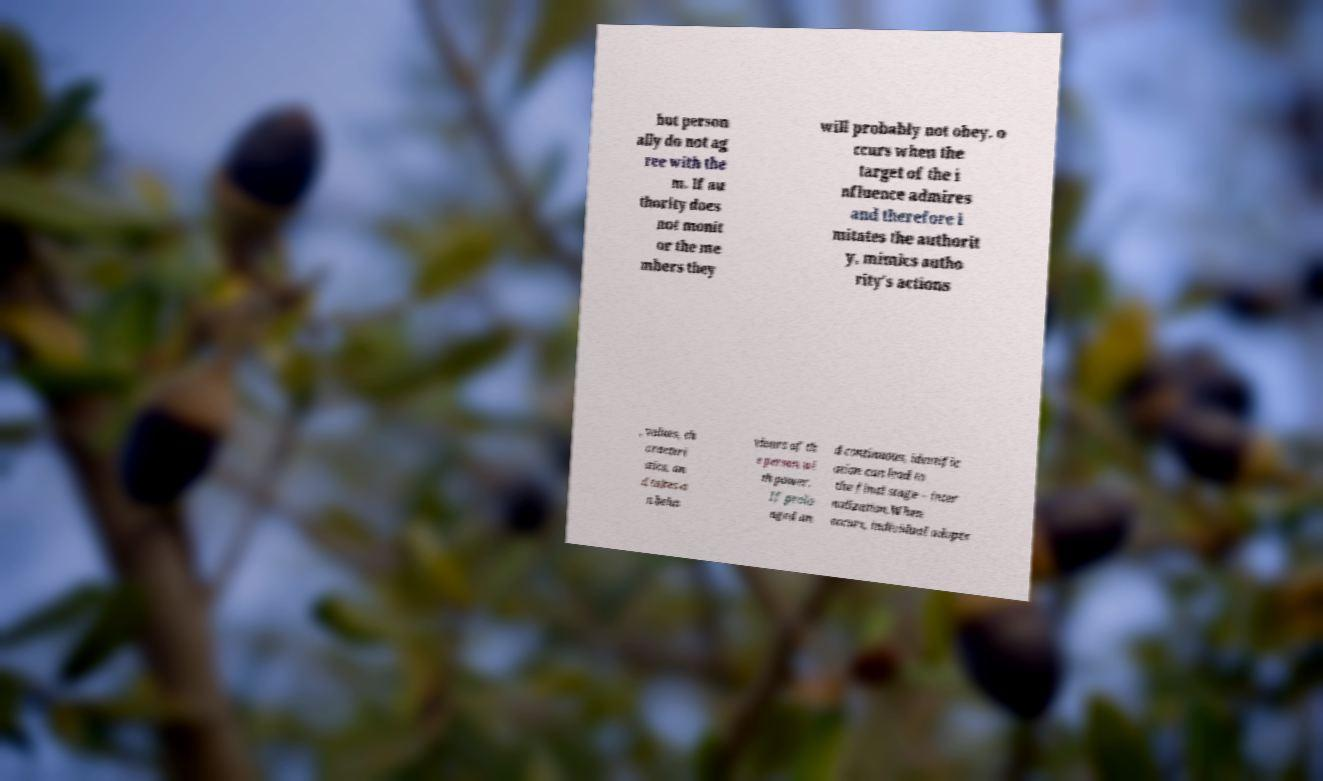Could you extract and type out the text from this image? but person ally do not ag ree with the m. If au thority does not monit or the me mbers they will probably not obey. o ccurs when the target of the i nfluence admires and therefore i mitates the authorit y, mimics autho rity's actions , values, ch aracteri stics, an d takes o n beha viours of th e person wi th power. If prolo nged an d continuous, identific ation can lead to the final stage – inter nalization.When occurs, individual adopts 